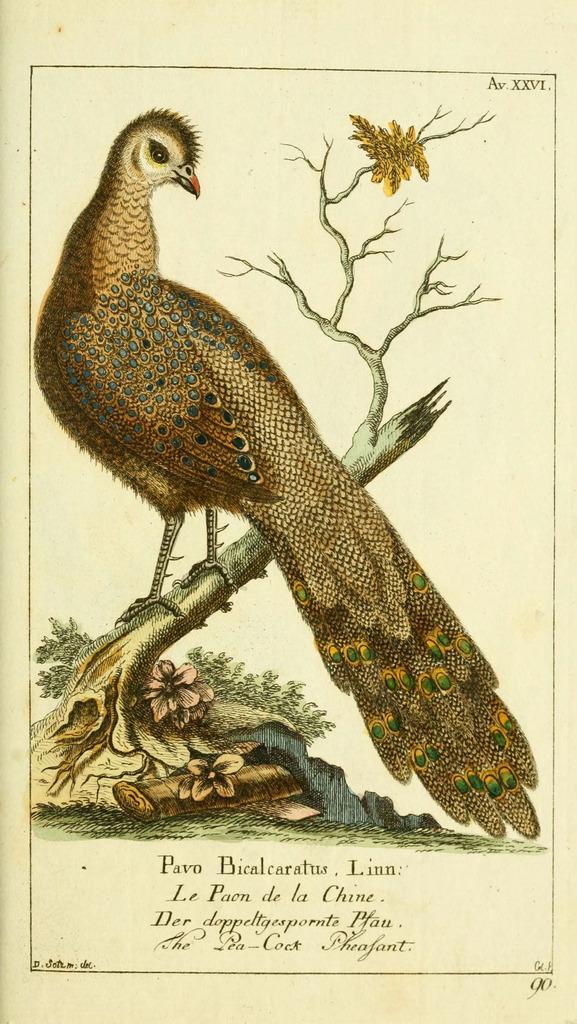Could you give a brief overview of what you see in this image? In this image I can see a poster. In this poster I can see an image of a peacock, branches, flowers and leaves. Something is written on the poster.   